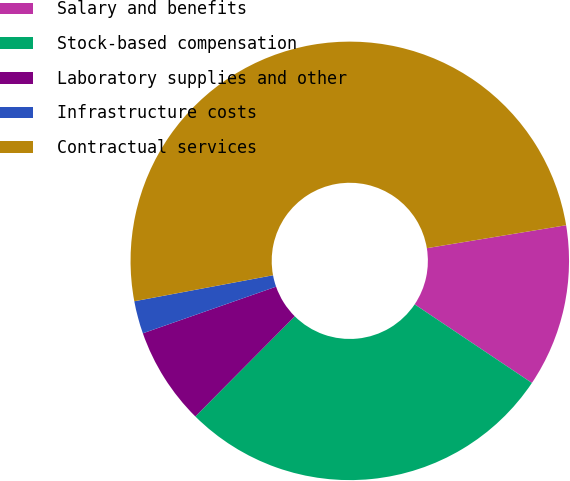<chart> <loc_0><loc_0><loc_500><loc_500><pie_chart><fcel>Salary and benefits<fcel>Stock-based compensation<fcel>Laboratory supplies and other<fcel>Infrastructure costs<fcel>Contractual services<nl><fcel>12.0%<fcel>28.04%<fcel>7.2%<fcel>2.41%<fcel>50.35%<nl></chart> 